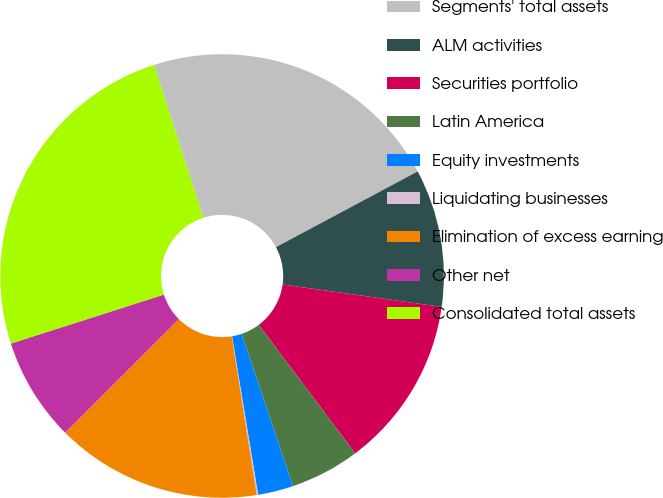Convert chart. <chart><loc_0><loc_0><loc_500><loc_500><pie_chart><fcel>Segments' total assets<fcel>ALM activities<fcel>Securities portfolio<fcel>Latin America<fcel>Equity investments<fcel>Liquidating businesses<fcel>Elimination of excess earning<fcel>Other net<fcel>Consolidated total assets<nl><fcel>22.16%<fcel>10.04%<fcel>12.53%<fcel>5.07%<fcel>2.58%<fcel>0.1%<fcel>15.01%<fcel>7.56%<fcel>24.96%<nl></chart> 